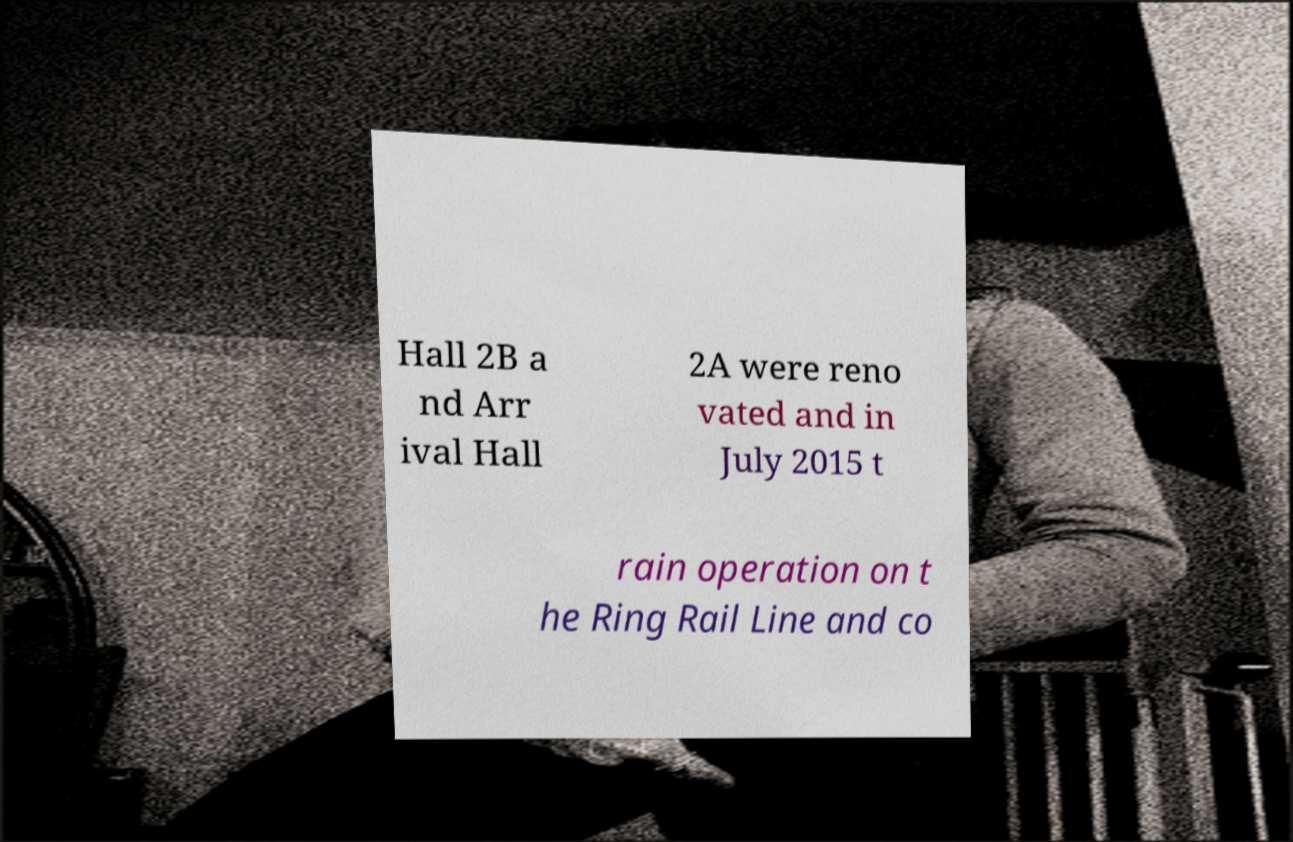What messages or text are displayed in this image? I need them in a readable, typed format. Hall 2B a nd Arr ival Hall 2A were reno vated and in July 2015 t rain operation on t he Ring Rail Line and co 